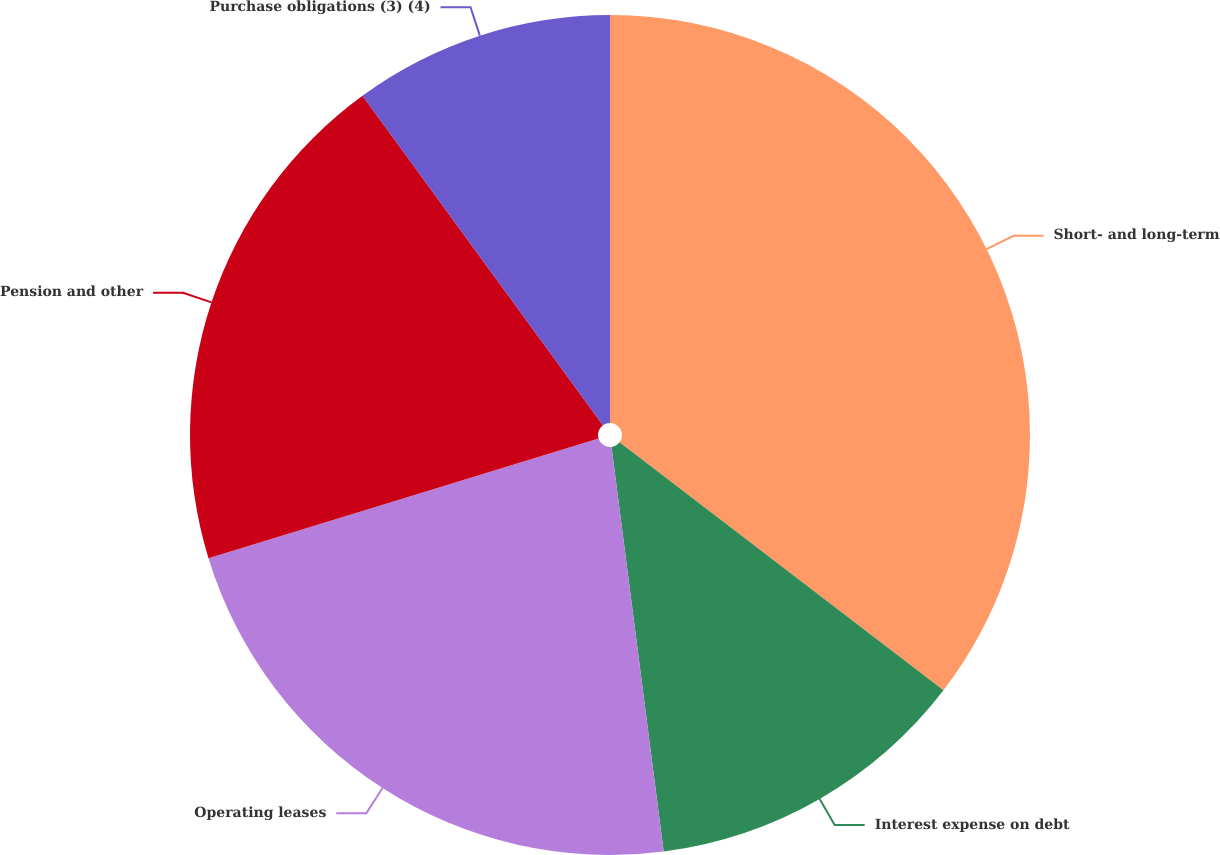<chart> <loc_0><loc_0><loc_500><loc_500><pie_chart><fcel>Short- and long-term<fcel>Interest expense on debt<fcel>Operating leases<fcel>Pension and other<fcel>Purchase obligations (3) (4)<nl><fcel>35.4%<fcel>12.56%<fcel>22.3%<fcel>19.71%<fcel>10.03%<nl></chart> 